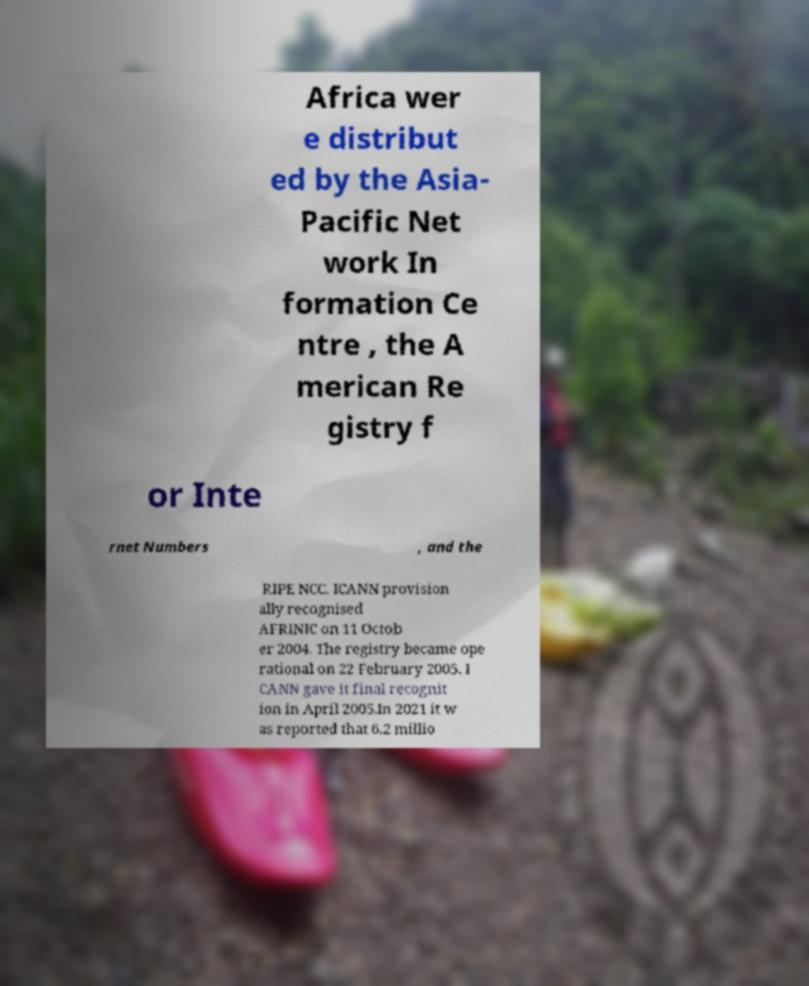For documentation purposes, I need the text within this image transcribed. Could you provide that? Africa wer e distribut ed by the Asia- Pacific Net work In formation Ce ntre , the A merican Re gistry f or Inte rnet Numbers , and the RIPE NCC. ICANN provision ally recognised AFRINIC on 11 Octob er 2004. The registry became ope rational on 22 February 2005. I CANN gave it final recognit ion in April 2005.In 2021 it w as reported that 6.2 millio 